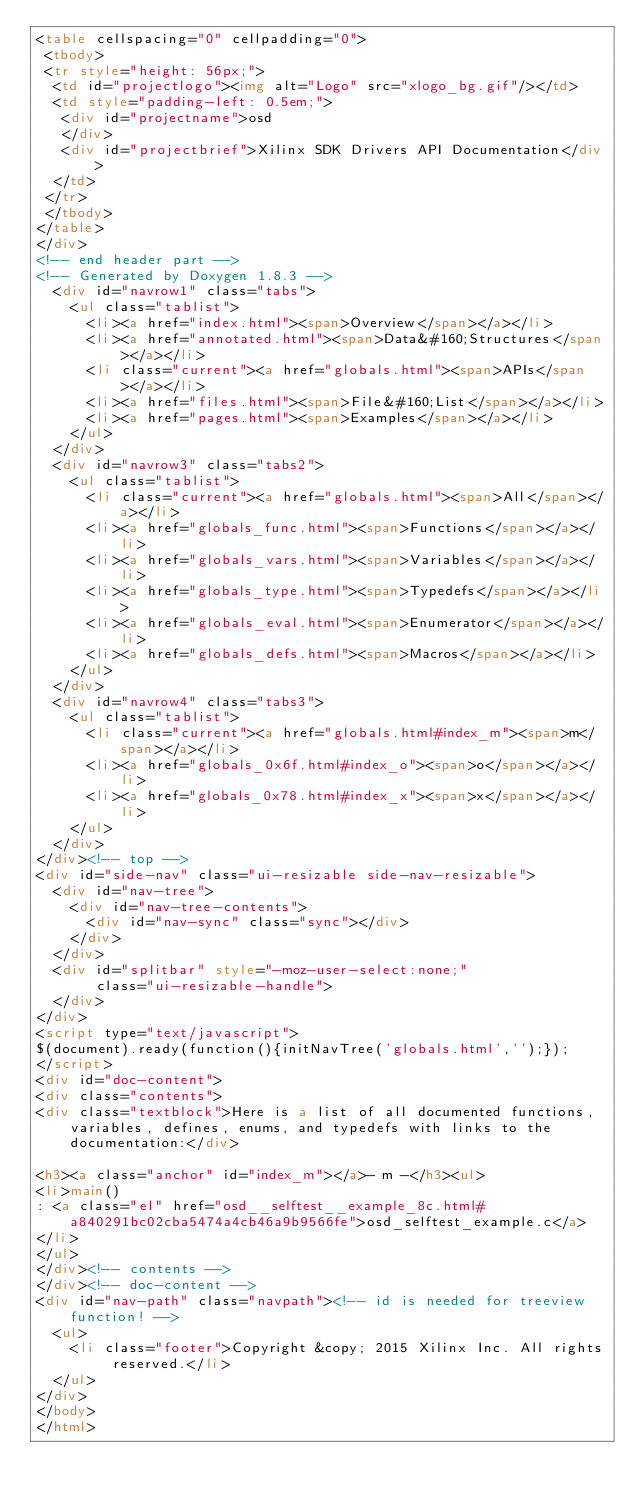<code> <loc_0><loc_0><loc_500><loc_500><_HTML_><table cellspacing="0" cellpadding="0">
 <tbody>
 <tr style="height: 56px;">
  <td id="projectlogo"><img alt="Logo" src="xlogo_bg.gif"/></td>
  <td style="padding-left: 0.5em;">
   <div id="projectname">osd
   </div>
   <div id="projectbrief">Xilinx SDK Drivers API Documentation</div>
  </td>
 </tr>
 </tbody>
</table>
</div>
<!-- end header part -->
<!-- Generated by Doxygen 1.8.3 -->
  <div id="navrow1" class="tabs">
    <ul class="tablist">
      <li><a href="index.html"><span>Overview</span></a></li>
      <li><a href="annotated.html"><span>Data&#160;Structures</span></a></li>
      <li class="current"><a href="globals.html"><span>APIs</span></a></li>
      <li><a href="files.html"><span>File&#160;List</span></a></li>
      <li><a href="pages.html"><span>Examples</span></a></li>
    </ul>
  </div>
  <div id="navrow3" class="tabs2">
    <ul class="tablist">
      <li class="current"><a href="globals.html"><span>All</span></a></li>
      <li><a href="globals_func.html"><span>Functions</span></a></li>
      <li><a href="globals_vars.html"><span>Variables</span></a></li>
      <li><a href="globals_type.html"><span>Typedefs</span></a></li>
      <li><a href="globals_eval.html"><span>Enumerator</span></a></li>
      <li><a href="globals_defs.html"><span>Macros</span></a></li>
    </ul>
  </div>
  <div id="navrow4" class="tabs3">
    <ul class="tablist">
      <li class="current"><a href="globals.html#index_m"><span>m</span></a></li>
      <li><a href="globals_0x6f.html#index_o"><span>o</span></a></li>
      <li><a href="globals_0x78.html#index_x"><span>x</span></a></li>
    </ul>
  </div>
</div><!-- top -->
<div id="side-nav" class="ui-resizable side-nav-resizable">
  <div id="nav-tree">
    <div id="nav-tree-contents">
      <div id="nav-sync" class="sync"></div>
    </div>
  </div>
  <div id="splitbar" style="-moz-user-select:none;" 
       class="ui-resizable-handle">
  </div>
</div>
<script type="text/javascript">
$(document).ready(function(){initNavTree('globals.html','');});
</script>
<div id="doc-content">
<div class="contents">
<div class="textblock">Here is a list of all documented functions, variables, defines, enums, and typedefs with links to the documentation:</div>

<h3><a class="anchor" id="index_m"></a>- m -</h3><ul>
<li>main()
: <a class="el" href="osd__selftest__example_8c.html#a840291bc02cba5474a4cb46a9b9566fe">osd_selftest_example.c</a>
</li>
</ul>
</div><!-- contents -->
</div><!-- doc-content -->
<div id="nav-path" class="navpath"><!-- id is needed for treeview function! -->
  <ul>
    <li class="footer">Copyright &copy; 2015 Xilinx Inc. All rights reserved.</li>
  </ul>
</div>
</body>
</html>
</code> 